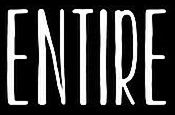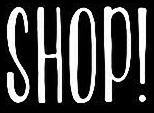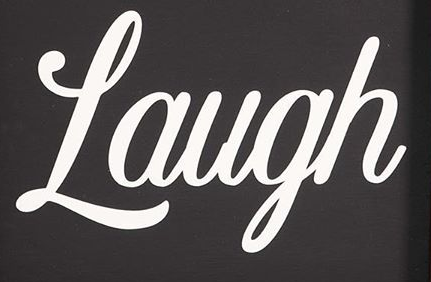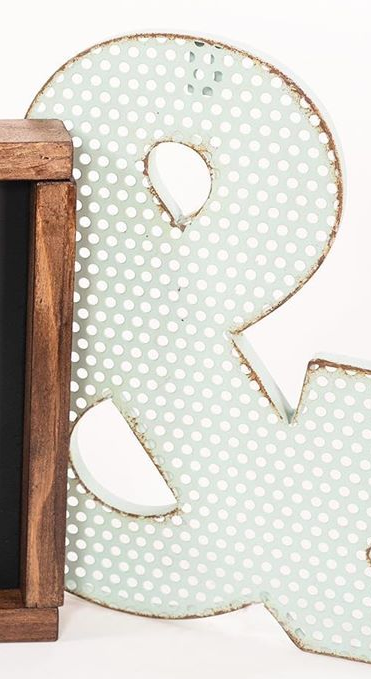What text appears in these images from left to right, separated by a semicolon? ENTIRE; SHOP!; Laugh; & 